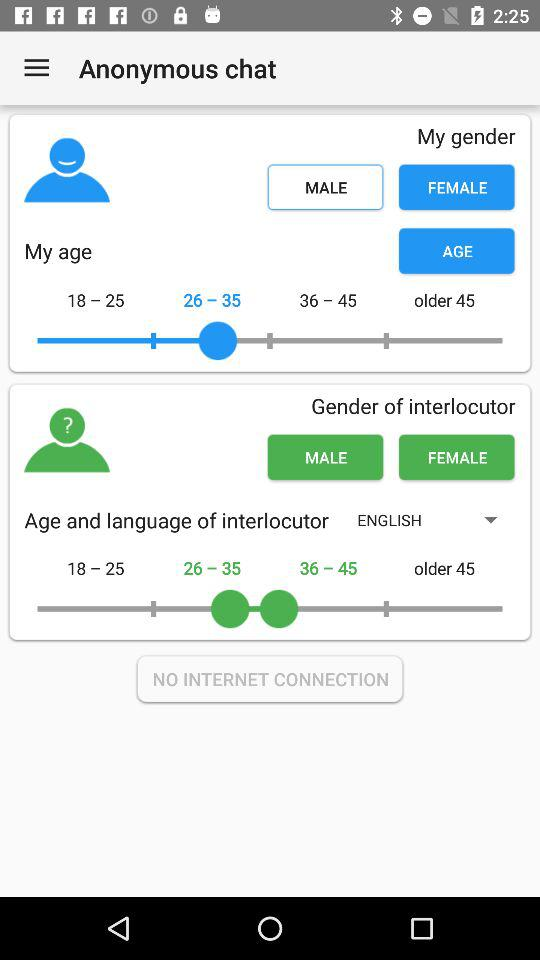Which is the selected language for the interlocutor? The selected language is English. 